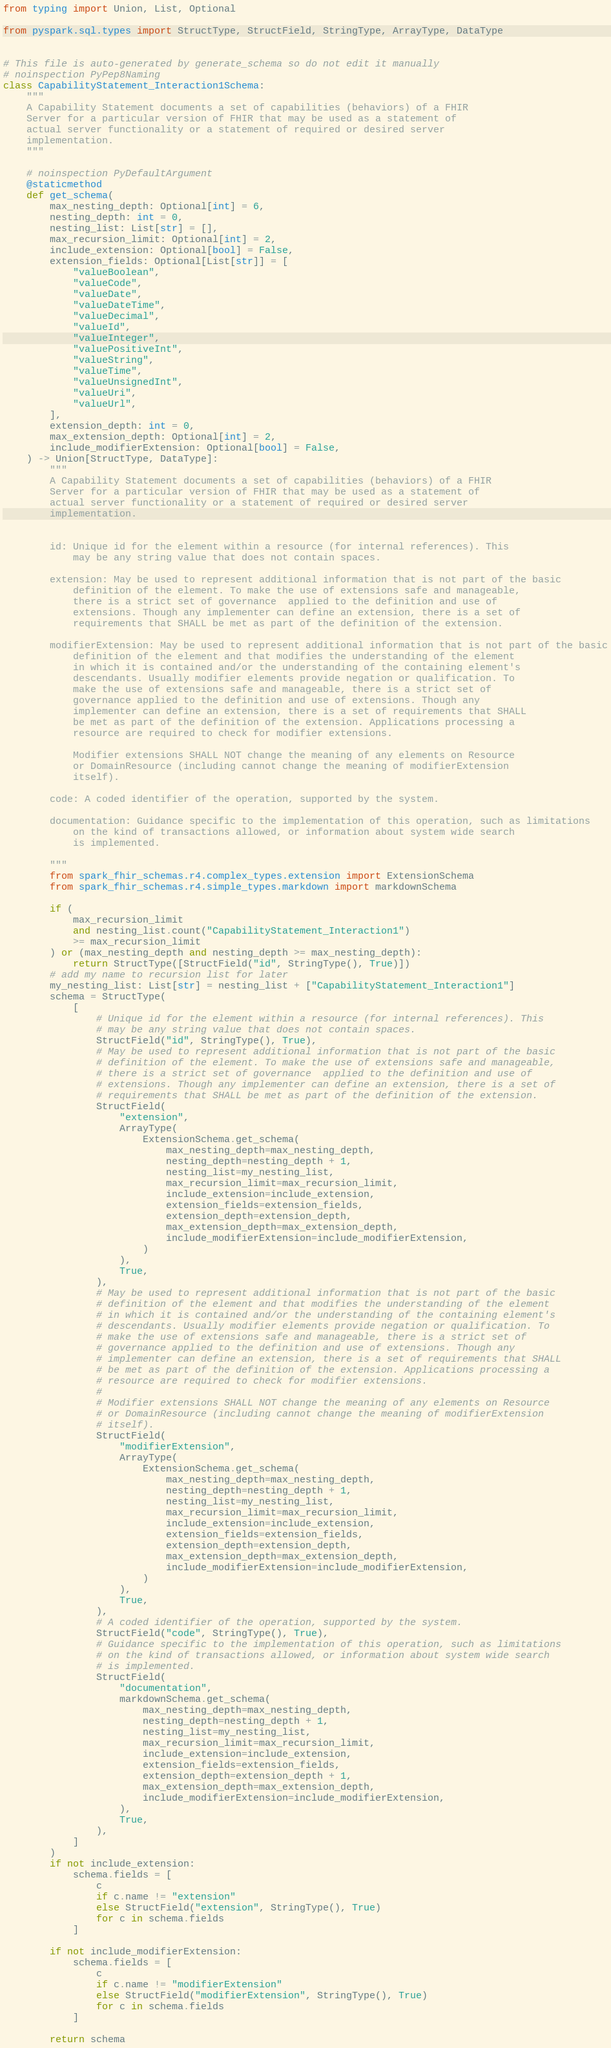<code> <loc_0><loc_0><loc_500><loc_500><_Python_>from typing import Union, List, Optional

from pyspark.sql.types import StructType, StructField, StringType, ArrayType, DataType


# This file is auto-generated by generate_schema so do not edit it manually
# noinspection PyPep8Naming
class CapabilityStatement_Interaction1Schema:
    """
    A Capability Statement documents a set of capabilities (behaviors) of a FHIR
    Server for a particular version of FHIR that may be used as a statement of
    actual server functionality or a statement of required or desired server
    implementation.
    """

    # noinspection PyDefaultArgument
    @staticmethod
    def get_schema(
        max_nesting_depth: Optional[int] = 6,
        nesting_depth: int = 0,
        nesting_list: List[str] = [],
        max_recursion_limit: Optional[int] = 2,
        include_extension: Optional[bool] = False,
        extension_fields: Optional[List[str]] = [
            "valueBoolean",
            "valueCode",
            "valueDate",
            "valueDateTime",
            "valueDecimal",
            "valueId",
            "valueInteger",
            "valuePositiveInt",
            "valueString",
            "valueTime",
            "valueUnsignedInt",
            "valueUri",
            "valueUrl",
        ],
        extension_depth: int = 0,
        max_extension_depth: Optional[int] = 2,
        include_modifierExtension: Optional[bool] = False,
    ) -> Union[StructType, DataType]:
        """
        A Capability Statement documents a set of capabilities (behaviors) of a FHIR
        Server for a particular version of FHIR that may be used as a statement of
        actual server functionality or a statement of required or desired server
        implementation.


        id: Unique id for the element within a resource (for internal references). This
            may be any string value that does not contain spaces.

        extension: May be used to represent additional information that is not part of the basic
            definition of the element. To make the use of extensions safe and manageable,
            there is a strict set of governance  applied to the definition and use of
            extensions. Though any implementer can define an extension, there is a set of
            requirements that SHALL be met as part of the definition of the extension.

        modifierExtension: May be used to represent additional information that is not part of the basic
            definition of the element and that modifies the understanding of the element
            in which it is contained and/or the understanding of the containing element's
            descendants. Usually modifier elements provide negation or qualification. To
            make the use of extensions safe and manageable, there is a strict set of
            governance applied to the definition and use of extensions. Though any
            implementer can define an extension, there is a set of requirements that SHALL
            be met as part of the definition of the extension. Applications processing a
            resource are required to check for modifier extensions.

            Modifier extensions SHALL NOT change the meaning of any elements on Resource
            or DomainResource (including cannot change the meaning of modifierExtension
            itself).

        code: A coded identifier of the operation, supported by the system.

        documentation: Guidance specific to the implementation of this operation, such as limitations
            on the kind of transactions allowed, or information about system wide search
            is implemented.

        """
        from spark_fhir_schemas.r4.complex_types.extension import ExtensionSchema
        from spark_fhir_schemas.r4.simple_types.markdown import markdownSchema

        if (
            max_recursion_limit
            and nesting_list.count("CapabilityStatement_Interaction1")
            >= max_recursion_limit
        ) or (max_nesting_depth and nesting_depth >= max_nesting_depth):
            return StructType([StructField("id", StringType(), True)])
        # add my name to recursion list for later
        my_nesting_list: List[str] = nesting_list + ["CapabilityStatement_Interaction1"]
        schema = StructType(
            [
                # Unique id for the element within a resource (for internal references). This
                # may be any string value that does not contain spaces.
                StructField("id", StringType(), True),
                # May be used to represent additional information that is not part of the basic
                # definition of the element. To make the use of extensions safe and manageable,
                # there is a strict set of governance  applied to the definition and use of
                # extensions. Though any implementer can define an extension, there is a set of
                # requirements that SHALL be met as part of the definition of the extension.
                StructField(
                    "extension",
                    ArrayType(
                        ExtensionSchema.get_schema(
                            max_nesting_depth=max_nesting_depth,
                            nesting_depth=nesting_depth + 1,
                            nesting_list=my_nesting_list,
                            max_recursion_limit=max_recursion_limit,
                            include_extension=include_extension,
                            extension_fields=extension_fields,
                            extension_depth=extension_depth,
                            max_extension_depth=max_extension_depth,
                            include_modifierExtension=include_modifierExtension,
                        )
                    ),
                    True,
                ),
                # May be used to represent additional information that is not part of the basic
                # definition of the element and that modifies the understanding of the element
                # in which it is contained and/or the understanding of the containing element's
                # descendants. Usually modifier elements provide negation or qualification. To
                # make the use of extensions safe and manageable, there is a strict set of
                # governance applied to the definition and use of extensions. Though any
                # implementer can define an extension, there is a set of requirements that SHALL
                # be met as part of the definition of the extension. Applications processing a
                # resource are required to check for modifier extensions.
                #
                # Modifier extensions SHALL NOT change the meaning of any elements on Resource
                # or DomainResource (including cannot change the meaning of modifierExtension
                # itself).
                StructField(
                    "modifierExtension",
                    ArrayType(
                        ExtensionSchema.get_schema(
                            max_nesting_depth=max_nesting_depth,
                            nesting_depth=nesting_depth + 1,
                            nesting_list=my_nesting_list,
                            max_recursion_limit=max_recursion_limit,
                            include_extension=include_extension,
                            extension_fields=extension_fields,
                            extension_depth=extension_depth,
                            max_extension_depth=max_extension_depth,
                            include_modifierExtension=include_modifierExtension,
                        )
                    ),
                    True,
                ),
                # A coded identifier of the operation, supported by the system.
                StructField("code", StringType(), True),
                # Guidance specific to the implementation of this operation, such as limitations
                # on the kind of transactions allowed, or information about system wide search
                # is implemented.
                StructField(
                    "documentation",
                    markdownSchema.get_schema(
                        max_nesting_depth=max_nesting_depth,
                        nesting_depth=nesting_depth + 1,
                        nesting_list=my_nesting_list,
                        max_recursion_limit=max_recursion_limit,
                        include_extension=include_extension,
                        extension_fields=extension_fields,
                        extension_depth=extension_depth + 1,
                        max_extension_depth=max_extension_depth,
                        include_modifierExtension=include_modifierExtension,
                    ),
                    True,
                ),
            ]
        )
        if not include_extension:
            schema.fields = [
                c
                if c.name != "extension"
                else StructField("extension", StringType(), True)
                for c in schema.fields
            ]

        if not include_modifierExtension:
            schema.fields = [
                c
                if c.name != "modifierExtension"
                else StructField("modifierExtension", StringType(), True)
                for c in schema.fields
            ]

        return schema
</code> 